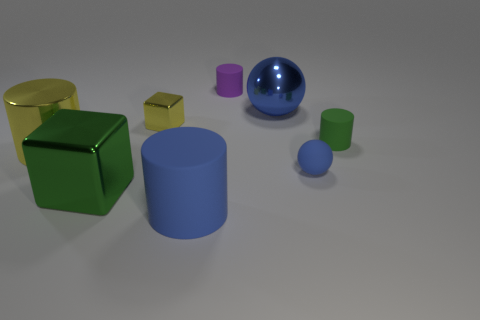Subtract 1 cylinders. How many cylinders are left? 3 Subtract all red cylinders. Subtract all yellow spheres. How many cylinders are left? 4 Add 1 big blue metallic objects. How many objects exist? 9 Subtract all blocks. How many objects are left? 6 Subtract 1 purple cylinders. How many objects are left? 7 Subtract all large yellow shiny objects. Subtract all big green blocks. How many objects are left? 6 Add 4 tiny yellow blocks. How many tiny yellow blocks are left? 5 Add 2 tiny purple matte cylinders. How many tiny purple matte cylinders exist? 3 